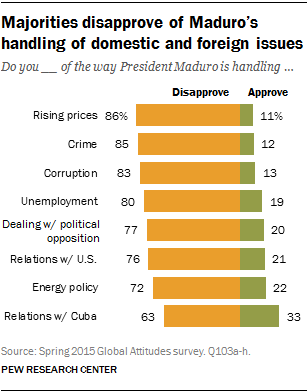Specify some key components in this picture. According to the data provided, 0.17% of those surveyed approve of the way that energy and crime are being handled. The bar with the shortest green length is... 